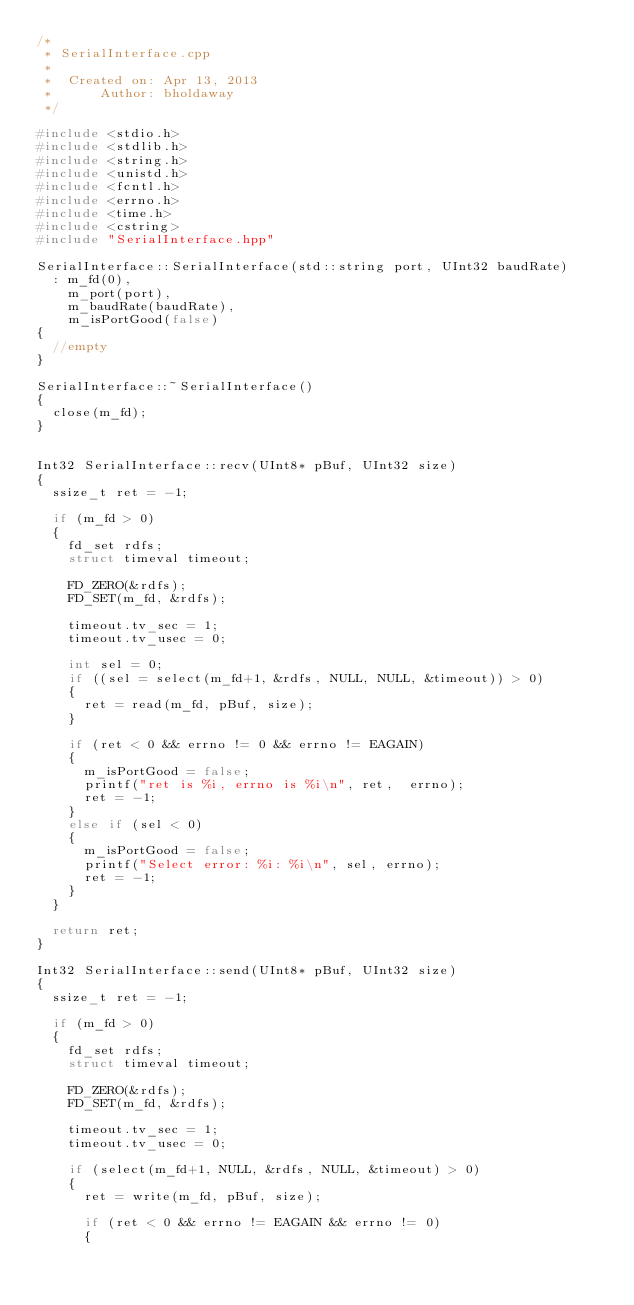<code> <loc_0><loc_0><loc_500><loc_500><_C++_>/*
 * SerialInterface.cpp
 *
 *  Created on: Apr 13, 2013
 *      Author: bholdaway
 */

#include <stdio.h>
#include <stdlib.h>
#include <string.h>
#include <unistd.h>
#include <fcntl.h>
#include <errno.h>
#include <time.h>
#include <cstring>
#include "SerialInterface.hpp"

SerialInterface::SerialInterface(std::string port, UInt32 baudRate)
  : m_fd(0),
    m_port(port),
    m_baudRate(baudRate),
    m_isPortGood(false)
{
  //empty
}

SerialInterface::~SerialInterface()
{
  close(m_fd);
}


Int32 SerialInterface::recv(UInt8* pBuf, UInt32 size)
{
  ssize_t ret = -1;

  if (m_fd > 0)
  {
    fd_set rdfs;
    struct timeval timeout;

    FD_ZERO(&rdfs);
    FD_SET(m_fd, &rdfs);

    timeout.tv_sec = 1;
    timeout.tv_usec = 0;

    int sel = 0;
    if ((sel = select(m_fd+1, &rdfs, NULL, NULL, &timeout)) > 0)
    {
      ret = read(m_fd, pBuf, size);
    }

    if (ret < 0 && errno != 0 && errno != EAGAIN)
    {
      m_isPortGood = false;
      printf("ret is %i, errno is %i\n", ret,  errno);
      ret = -1;
    }
    else if (sel < 0)
    {
      m_isPortGood = false;
      printf("Select error: %i: %i\n", sel, errno);
      ret = -1;
    }
  }

  return ret;
}

Int32 SerialInterface::send(UInt8* pBuf, UInt32 size)
{
  ssize_t ret = -1;

  if (m_fd > 0)
  {
    fd_set rdfs;
    struct timeval timeout;

    FD_ZERO(&rdfs);
    FD_SET(m_fd, &rdfs);

    timeout.tv_sec = 1;
    timeout.tv_usec = 0;

    if (select(m_fd+1, NULL, &rdfs, NULL, &timeout) > 0)
    {
      ret = write(m_fd, pBuf, size);

      if (ret < 0 && errno != EAGAIN && errno != 0)
      {</code> 